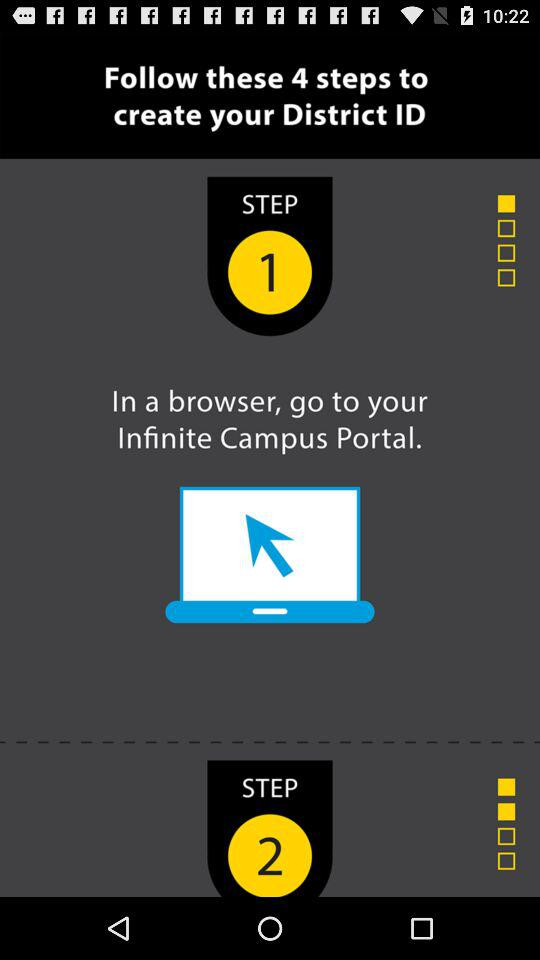How many steps are there in the process?
Answer the question using a single word or phrase. 4 